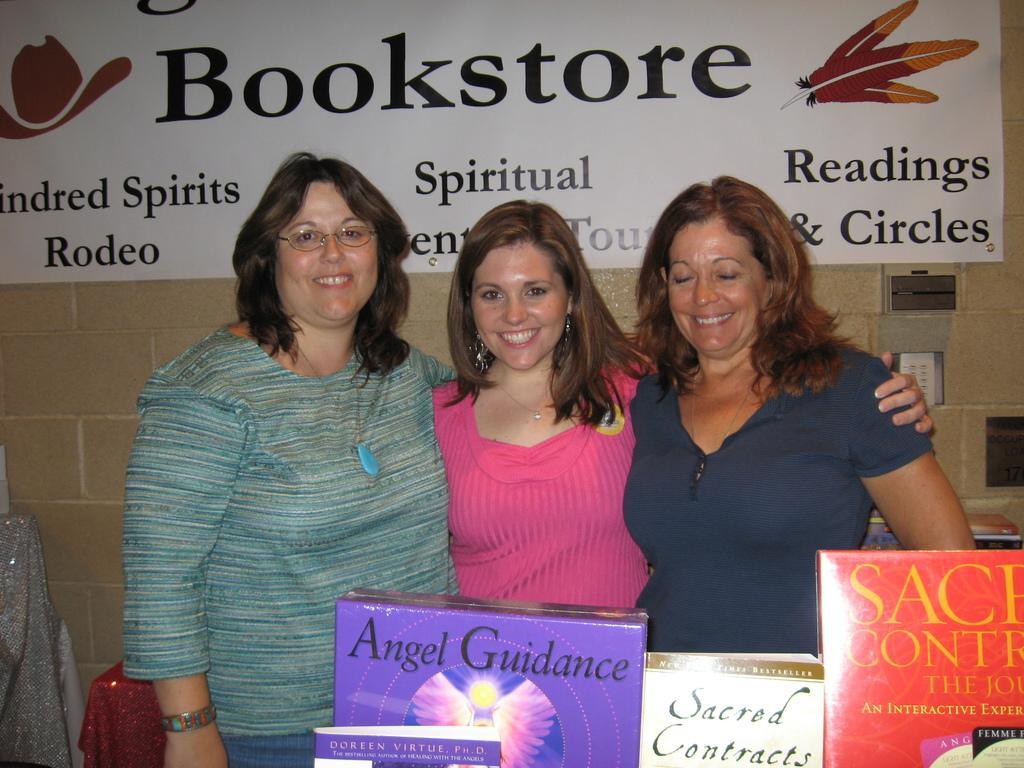Please provide a concise description of this image. In this picture we can see three women standing and smiling and in front of them we can see boxes and in the background we can see a banner on the wall. 